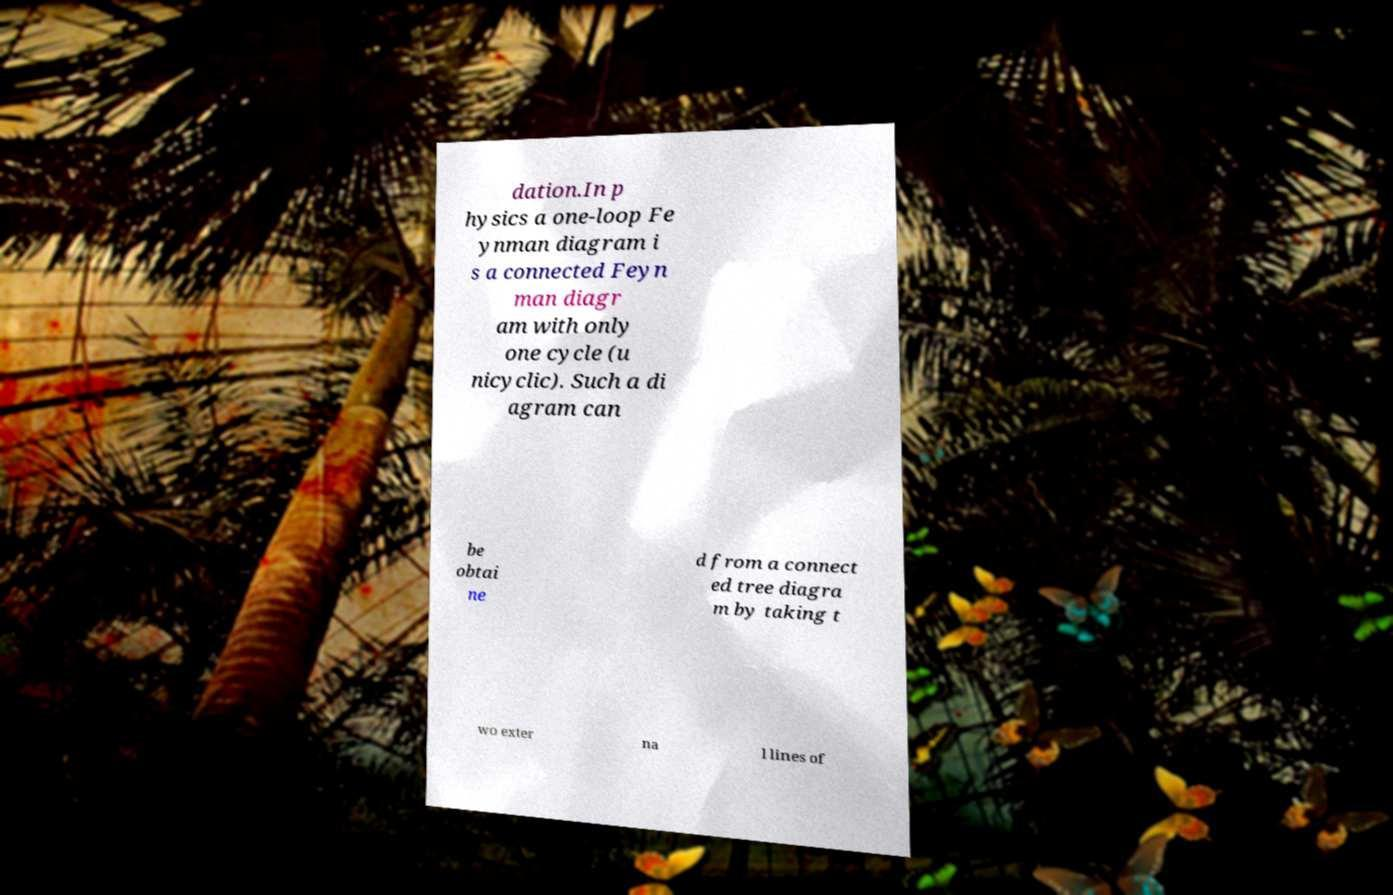There's text embedded in this image that I need extracted. Can you transcribe it verbatim? dation.In p hysics a one-loop Fe ynman diagram i s a connected Feyn man diagr am with only one cycle (u nicyclic). Such a di agram can be obtai ne d from a connect ed tree diagra m by taking t wo exter na l lines of 